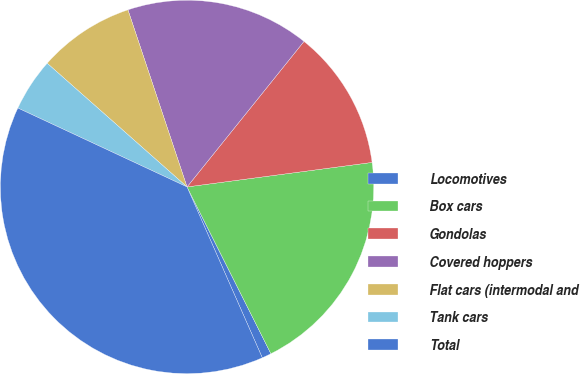Convert chart. <chart><loc_0><loc_0><loc_500><loc_500><pie_chart><fcel>Locomotives<fcel>Box cars<fcel>Gondolas<fcel>Covered hoppers<fcel>Flat cars (intermodal and<fcel>Tank cars<fcel>Total<nl><fcel>0.81%<fcel>19.68%<fcel>12.13%<fcel>15.9%<fcel>8.35%<fcel>4.58%<fcel>38.55%<nl></chart> 